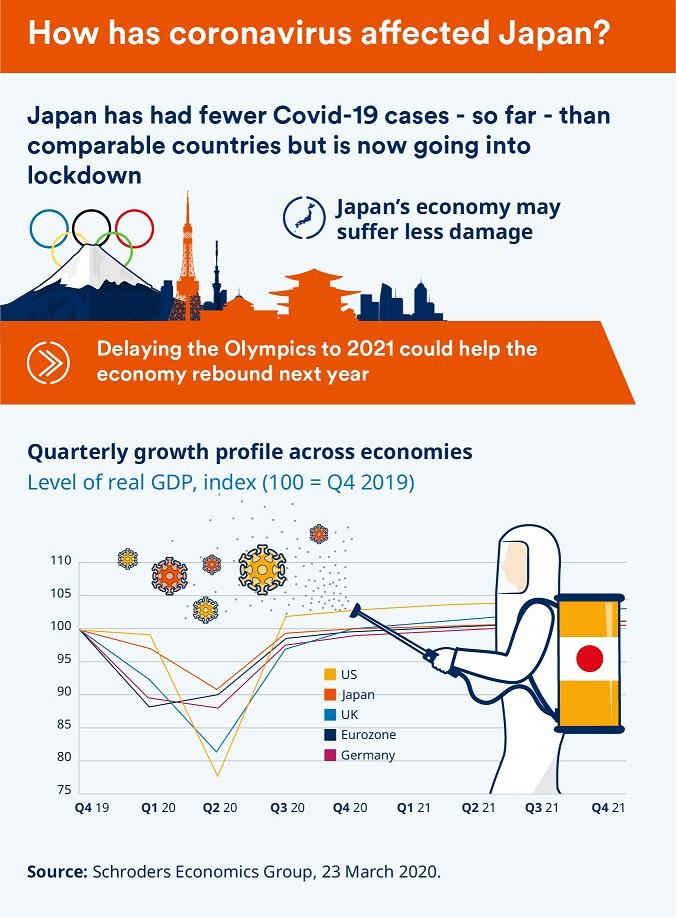Give some essential details in this illustration. According to the information provided, the country with a growth rate between Germany and the United States is the United Kingdom. The United Kingdom had the second lowest Gross Domestic Product (GDP) in the second quarter of 2020. The Eurozone has the second highest GDP among all regions. 